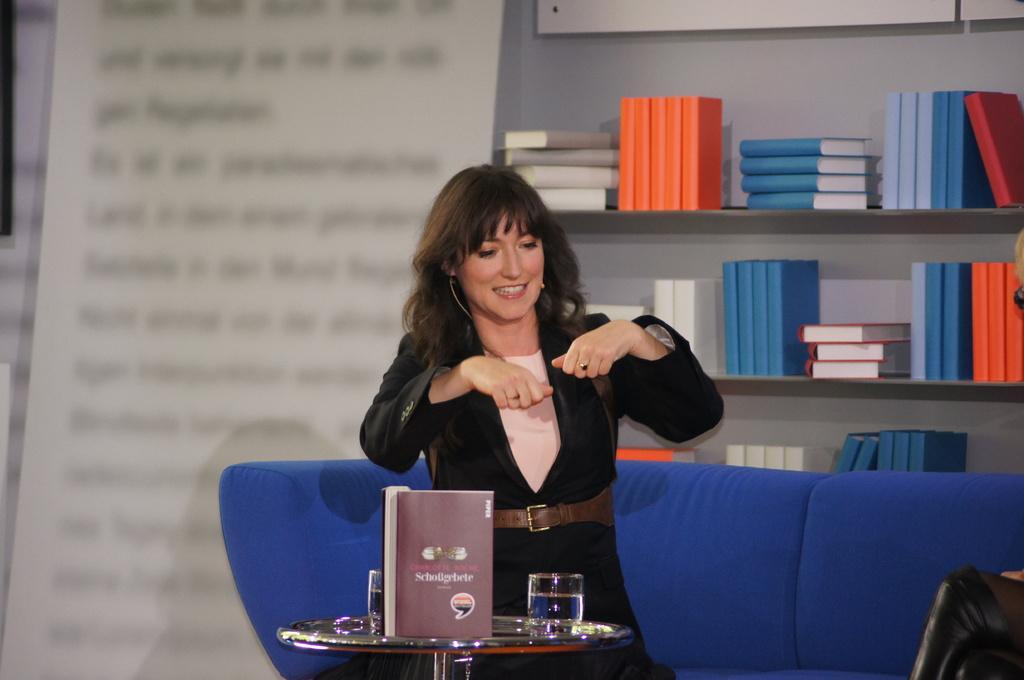Can you describe this image briefly? In this image we can see a woman is sitting on the sofa. In front of the women, we can see a table. On the table, we can see a book and glasses. In the background, we can see a banner and so many books are arranged on the shelves. We can see one more person on the left side of the image. 